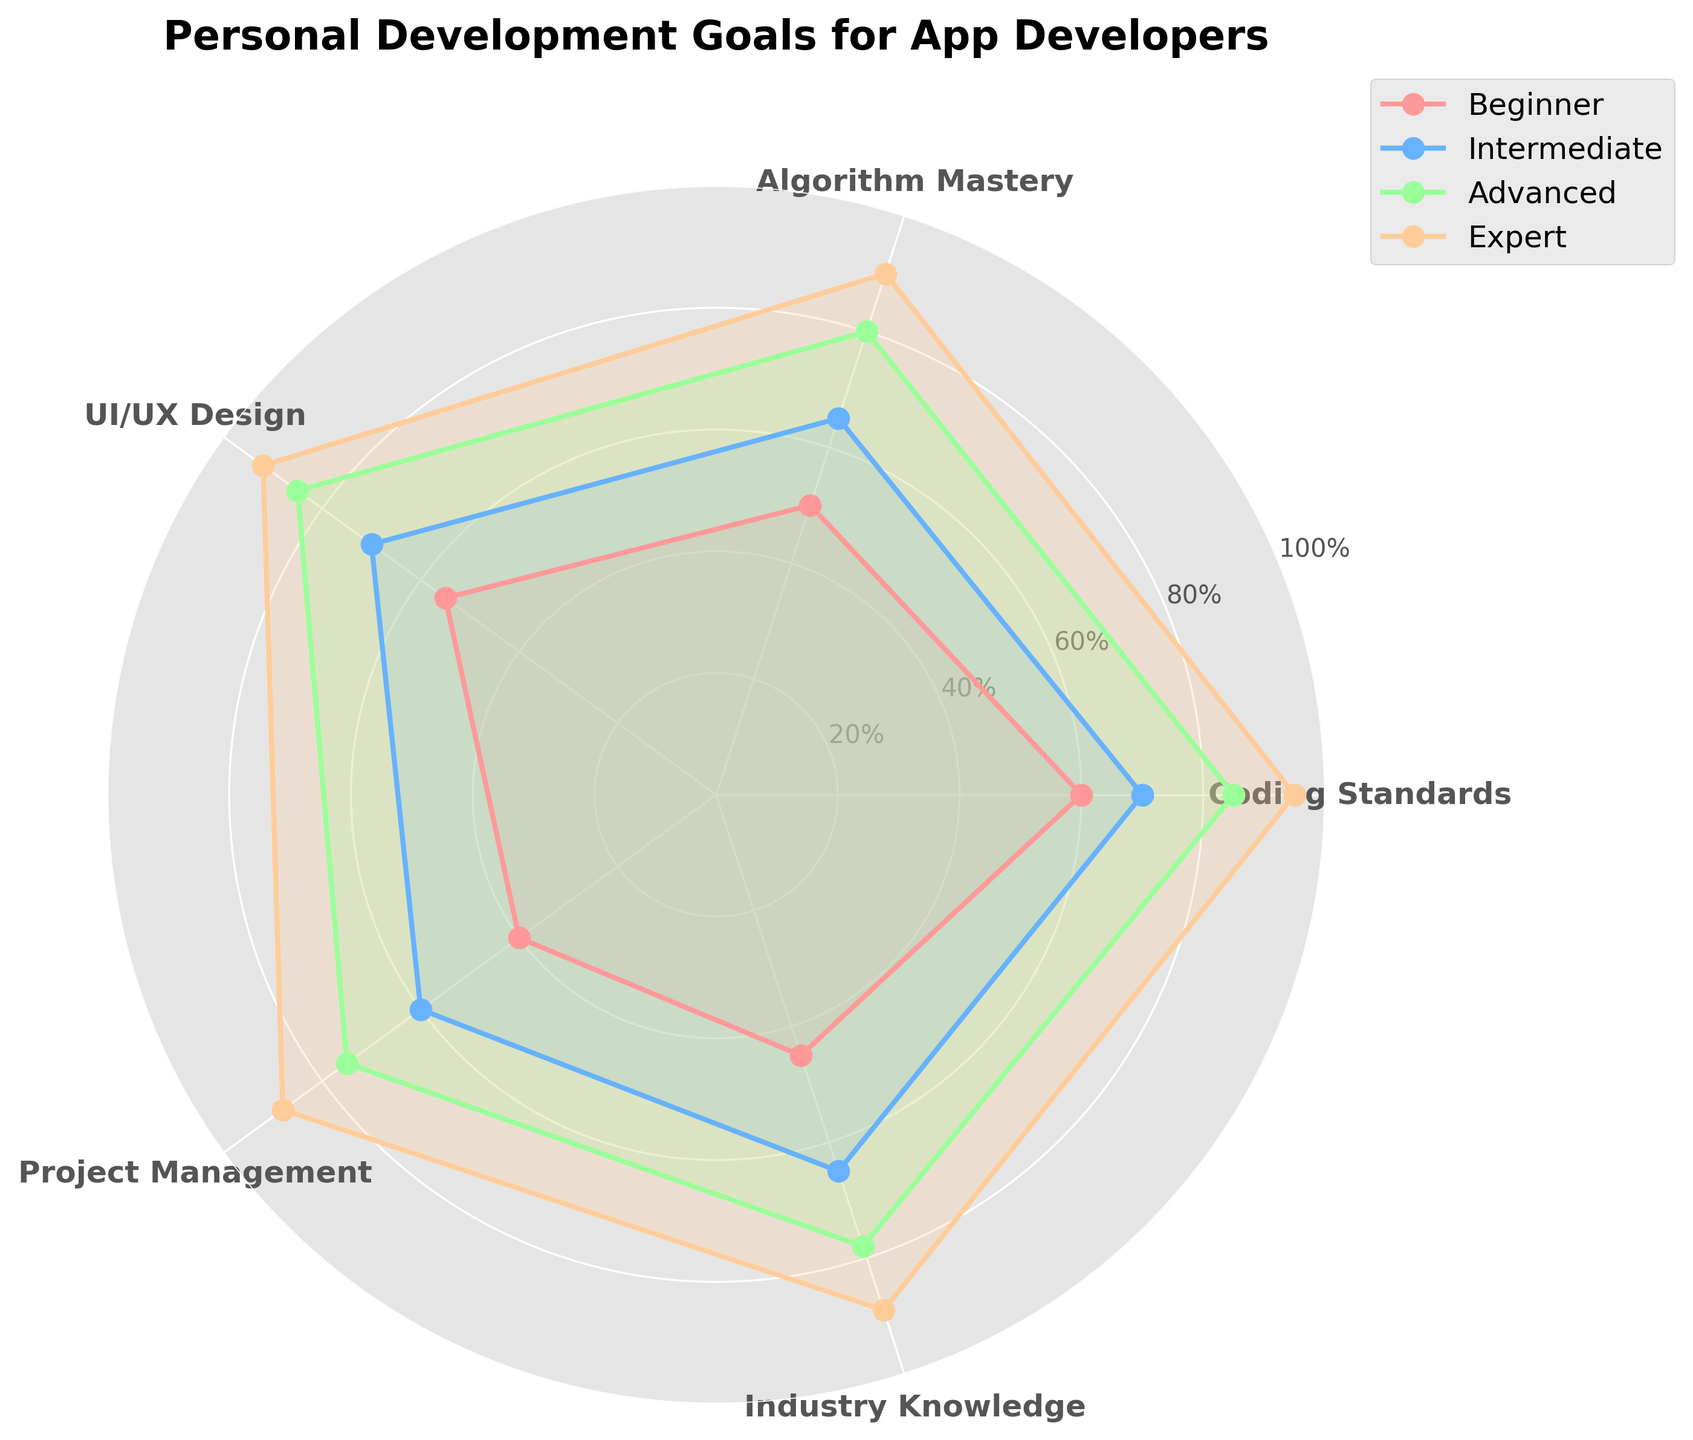What is the title of the radar chart? The title is usually found at the top of the chart and indicates the subject of the data visualization. In this radar chart, it reads "Personal Development Goals for App Developers".
Answer: Personal Development Goals for App Developers How many categories are displayed in the radar chart? By counting the number of unique labels around the radar chart, we can determine that there are five categories.
Answer: Five Which category has the highest value for the "Expert" level? Locate the "Expert" line (the outermost line) and find the peak point. It’s highest at "Coding Standards".
Answer: Coding Standards For the "Intermediate" level, which category has the lowest value? Follow the "Intermediate" line (likely the second from the inner circle) and find the lowest point, which falls at "Project Management".
Answer: Project Management What's the average "Expert" level across all categories? Sum the "Expert" values (95, 90, 92, 88, 89), then divide by the number of categories (5). Calculation: (95 + 90 + 92 + 88 + 89) / 5 = 90.8.
Answer: 90.8 Which level of proficiency has the greatest range for "UI/UX Design"? Calculate the range (difference between the highest and lowest values) for each proficiency level in "UI/UX Design". The ranges are Beginner-Expert (92-55=37), Intermediate-Expert (92-70=22), and Advanced-Expert (92-85=7). The greatest range is for "Beginner".
Answer: Beginner Does "Algorithm Mastery" have a higher score at the "Advanced" level compared to "UI/UX Design"? Compare the "Advanced" values for both categories, "Algorithm Mastery" (80) and "UI/UX Design" (85). "UI/UX Design" has a higher score.
Answer: No What is the difference between the "Beginner" level of "Project Management" and "Industry Knowledge"? Subtract the "Beginner" value of "Project Management" (40) from "Industry Knowledge" (45). Calculation: 45 - 40 = 5.
Answer: 5 Which category shows the greatest improvement from "Beginner" to "Expert"? Calculate the improvement (difference) for each category from "Beginner" to "Expert" and find the maximum difference. "Coding Standards" shows an improvement of (95 - 60) = 35, which is the highest.
Answer: Coding Standards Place the categories in order of their "Advanced" level values from highest to lowest. By observing and ordering the "Advanced" values: "UI/UX Design" (85), "Coding Standards" (85), "Algorithm Mastery" (80), "Industry Knowledge" (78), "Project Management" (75).
Answer: "UI/UX Design", "Coding Standards", "Algorithm Mastery", "Industry Knowledge", "Project Management" 